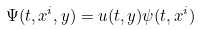Convert formula to latex. <formula><loc_0><loc_0><loc_500><loc_500>\Psi ( t , x ^ { i } , y ) = u ( t , y ) \psi ( t , x ^ { i } )</formula> 